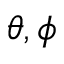Convert formula to latex. <formula><loc_0><loc_0><loc_500><loc_500>\theta , \phi</formula> 